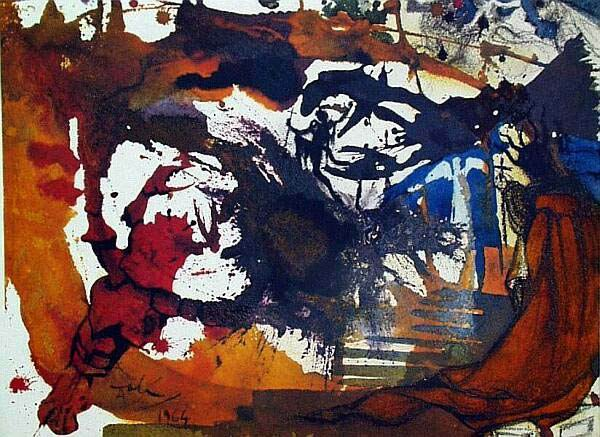Explain the visual content of the image in great detail. The image is an enthralling example of modern abstract expressionism. The artwork features a vibrant and chaotic blend of colors and textures that evoke a sense of dynamism and intensity. Dominated by hues of red, blue, and brown, with splashes of white and black, the piece portrays a lively and almost tumultuous atmosphere. The artist's use of bold lines and dynamic brushstrokes suggests movement and spontaneity, implying an emotional or energetic outpouring. The medium appears to be oil paints, adding to the depth and richness of the color palette. The overall composition is distinctly abstract, inviting viewers to engage their imagination and derive individual interpretations from the visual elements present. 